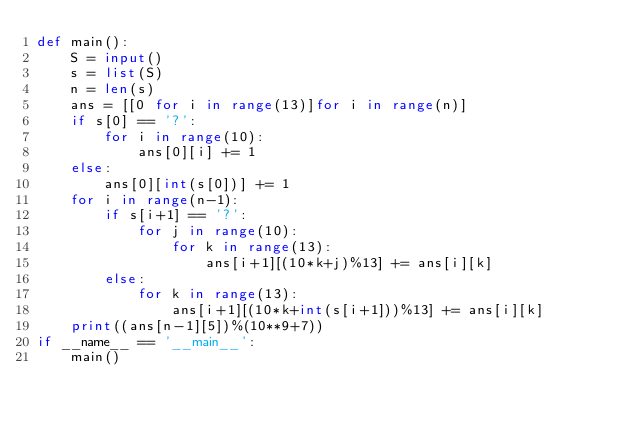<code> <loc_0><loc_0><loc_500><loc_500><_Python_>def main():
    S = input()
    s = list(S)
    n = len(s)
    ans = [[0 for i in range(13)]for i in range(n)]
    if s[0] == '?':
        for i in range(10):
            ans[0][i] += 1
    else:
        ans[0][int(s[0])] += 1
    for i in range(n-1):
        if s[i+1] == '?':
            for j in range(10):
                for k in range(13):
                    ans[i+1][(10*k+j)%13] += ans[i][k]
        else:
            for k in range(13):
                ans[i+1][(10*k+int(s[i+1]))%13] += ans[i][k]
    print((ans[n-1][5])%(10**9+7))
if __name__ == '__main__':
    main()</code> 